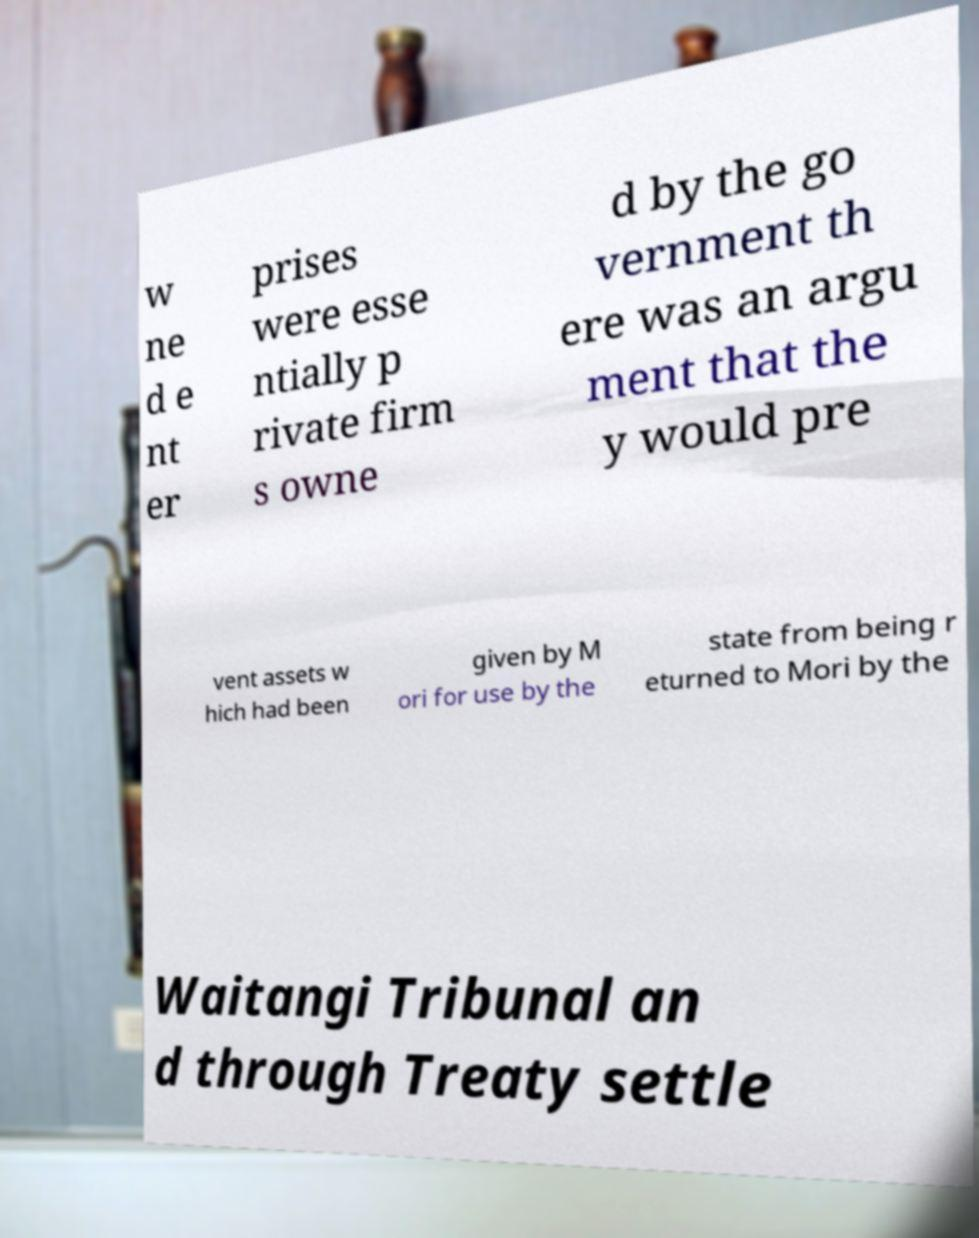What messages or text are displayed in this image? I need them in a readable, typed format. w ne d e nt er prises were esse ntially p rivate firm s owne d by the go vernment th ere was an argu ment that the y would pre vent assets w hich had been given by M ori for use by the state from being r eturned to Mori by the Waitangi Tribunal an d through Treaty settle 